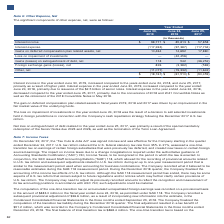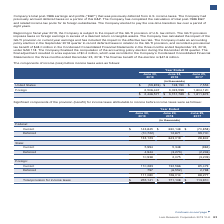According to Lam Research Corporation's financial document, What was the one-time transition tax on accumulated unrepatriated foreign earnings in the fiscal year ended June 24, 2018? According to the financial document, $883.0 million. The relevant text states: "s recorded on a provisional basis in the amount of $883.0 million in the fiscal year ended June 24, 2018, as permitted under SAB 118. The Company recorded a subsequen..." Also, What was the period of time the Company chose to pay the one-time transition tax? over a period of eight years. The document states: "ompany elected to pay the one-time transition tax over a period of eight years...." Also, What was the income before income taxes from United States in 2018? According to the financial document, $128,190 (in thousands). The relevant text states: "United States $ (59,876) $ 128,190 $ 7,553..." Also, can you calculate: What is the percentage change in the income before income taxes from United States from 2017 to 2018? To answer this question, I need to perform calculations using the financial data. The calculation is: (128,190-7,553)/7,553, which equals 1597.21 (percentage). This is based on the information: "United States $ (59,876) $ 128,190 $ 7,553 United States $ (59,876) $ 128,190 $ 7,553..." The key data points involved are: 128,190, 7,553. Also, can you calculate: What is the percentage change in the income before income taxes from Foreign countries from 2018 to 2019? To answer this question, I need to perform calculations using the financial data. The calculation is: (2,506,447-3,023,599)/3,023,599, which equals -17.1 (percentage). This is based on the information: "Foreign 2,506,447 3,023,599 1,804,120 Foreign 2,506,447 3,023,599 1,804,120..." The key data points involved are: 2,506,447, 3,023,599. Additionally, In which year is the income before income taxes from Foreign countries the highest? According to the financial document, 2018. The relevant text states: "June 30, 2019 June 24, 2018 June 25, 2017..." 